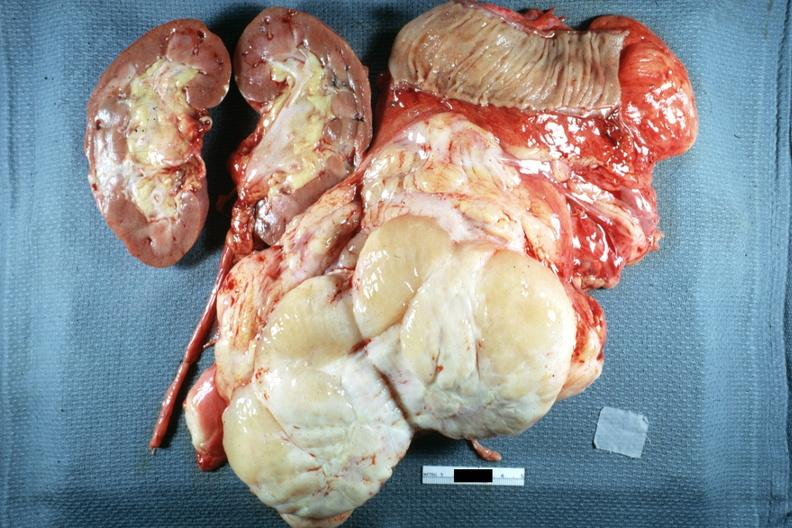s abdomen present?
Answer the question using a single word or phrase. Yes 